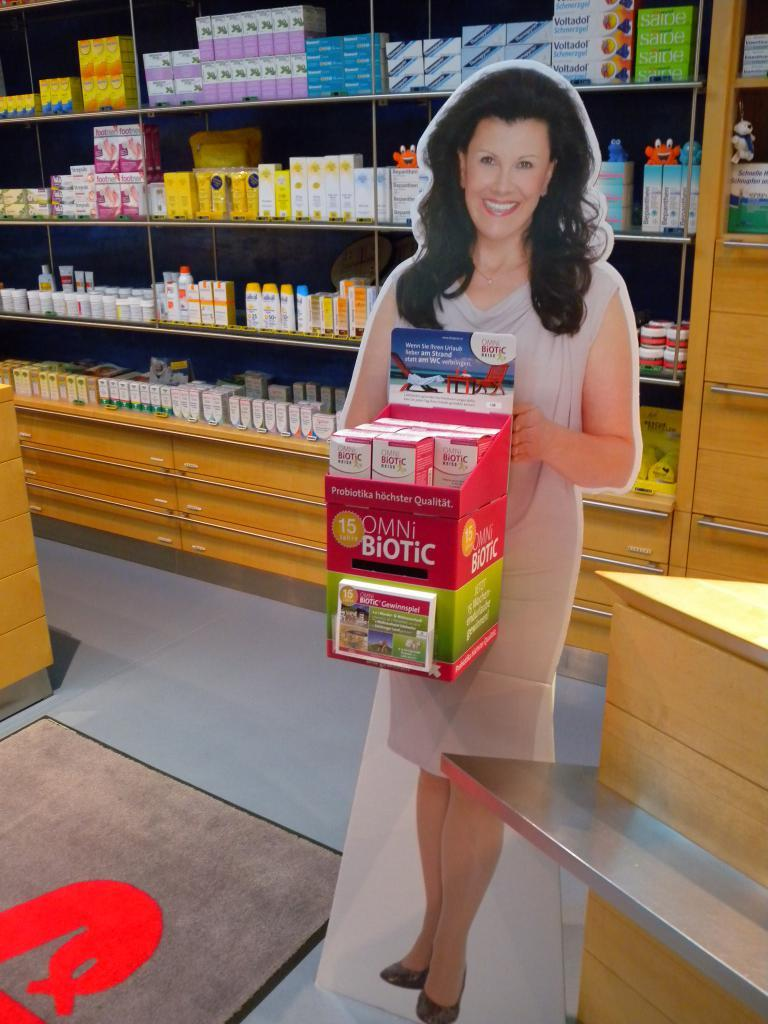<image>
Render a clear and concise summary of the photo. A cardboard cutout of a woman is holding boxes of OMNi BiOTiC. 